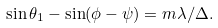Convert formula to latex. <formula><loc_0><loc_0><loc_500><loc_500>\sin \theta _ { 1 } - \sin ( \phi - \psi ) = m \lambda / \Delta .</formula> 